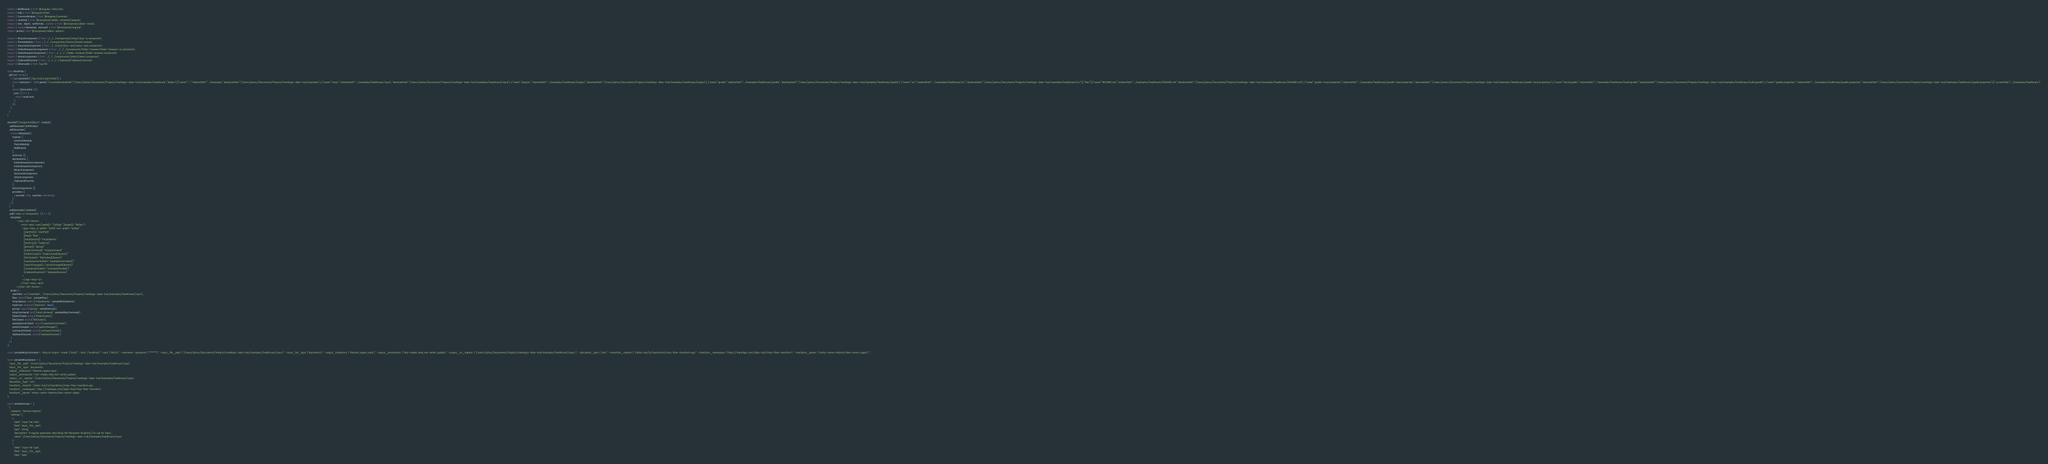Convert code to text. <code><loc_0><loc_0><loc_500><loc_500><_TypeScript_>import { MdlModule } from '@angular-mdl/core';
import { Http } from '@angular/http';
import { CommonModule } from '@angular/common';
import { centered } from '@storybook/addon-centered/angular';
import { text, object, withKnobs, boolean } from '@storybook/addon-knobs';
import { moduleMetadata, storiesOf } from '@storybook/angular';
import {action} from '@storybook/addon-actions';

import { MlcpUiComponent } from '../../../components/mlcp/mlcp-ui.component';
import { ThemeModule } from '../../../components/theme/theme.module';
import { StoryCardComponent } from '../../utils/story-card/story-card.component';
import { FolderBrowserUiComponent } from '../../../components/folder-browser/folder-browser-ui.component';
import { FolderBrowserComponent } from '../../../../folder-browser/folder-browser.component';
import { SelectComponent } from '../../../components/select/select.component';
import { ClipboardDirective } from '../../../../clipboard/clipboard.directive';
import { Observable } from 'rxjs/Rx';

class MockHttp {
  get(uri: string) {
    if (uri.startsWith('/api/utils/searchPath')) {
      const mockJson = JSON.parse('{"currentAbsolutePath":"/Users/pzhou/Documents/Projects/marklogic-data-hub/examples/healthcare","folders":[{"name":"..","relativePath":"../examples","absolutePath":"/Users/pzhou/Documents/Projects/marklogic-data-hub/examples"},{"name":"input","relativePath":"../examples/healthcare/input","absolutePath":"/Users/pzhou/Documents/Projects/marklogic-data-hub/examples/healthcare/input"},{"name":"plugins","relativePath":"../examples/healthcare/plugins","absolutePath":"/Users/pzhou/Documents/Projects/marklogic-data-hub/examples/healthcare/plugins"},{"name":"gradle","relativePath":"../examples/healthcare/gradle","absolutePath":"/Users/pzhou/Documents/Projects/marklogic-data-hub/examples/healthcare/gradle"},{"name":"src","relativePath":"../examples/healthcare/src","absolutePath":"/Users/pzhou/Documents/Projects/marklogic-data-hub/examples/healthcare/src"}],"files":[{"name":"README.md","relativePath":"../examples/healthcare/README.md","absolutePath":"/Users/pzhou/Documents/Projects/marklogic-data-hub/examples/healthcare/README.md"},{"name":"gradle-local.properties","relativePath":"../examples/healthcare/gradle-local.properties","absolutePath":"/Users/pzhou/Documents/Projects/marklogic-data-hub/examples/healthcare/gradle-local.properties"},{"name":"build.gradle","relativePath":"../examples/healthcare/build.gradle","absolutePath":"/Users/pzhou/Documents/Projects/marklogic-data-hub/examples/healthcare/build.gradle"},{"name":"gradle.properties","relativePath":"../examples/healthcare/gradle.properties","absolutePath":"/Users/pzhou/Documents/Projects/marklogic-data-hub/examples/healthcare/gradle.properties"}],"currentPath":"../examples/healthcare"}'
      );
      return Observable.of({
        json: () => {
          return mockJson;
        }
      });
    }
  }
}

storiesOf('Components|MLCP', module)
  .addDecorator(withKnobs)
  .addDecorator(
    moduleMetadata({
      imports: [
        CommonModule,
        ThemeModule,
        MdlModule
      ],
      schemas: [],
      declarations: [
        FolderBrowserUiComponent,
        FolderBrowserComponent,
        MlcpUiComponent,
        StoryCardComponent,
        SelectComponent,
        ClipboardDirective,
      ],
      entryComponents: [],
      providers: [
        { provide: Http, useClass: MockHttp}
      ]
    })
  )
  .addDecorator(centered)
  .add('mlcp-ui Component', () => ({
    template: `
            <mlui-dhf-theme>
                <mlui-story-card [width]="'1300px'" [height]="'800px'">
                  <app-mlcp-ui width="100%" min-width="500px"
                    [startPath]="startPath"
                    [flow]="flow"
                    [mlcpOptions]="mlcpOptions"
                    [hasErrors]="hasErrors"
                    [groups]="groups"
                    [mlcpCommand]="mlcpCommand"
                    (folderClicked)="folderClicked($event)"
                    (fileClicked)="fileClicked($event)"
                    (saveOptionsClicked)="saveOptionsClicked()"
                    (switchChanged)="switchChanged($event)"
                    (runImportClicked)="runImportClicked()"
                    (clipboardSuccess)="clipboardSuccess"
                  >
                  </app-mlcp-ui>
                </mlui-story-card>
           </mlui-dhf-theme>`,
    props: {
      startPath: text('startPath', '/Users/pzhou/Documents/Projects/marklogic-data-hub/examples/healthcare/input'),
      flow: object('flow', sampleFlow),
      mlcpOptions: object('mlcpOptions', sampleMlcpOptions),
      hasErrors: boolean('hasErrors', false),
      groups: object('groups', sampleGroups),
      mlcpCommand: text('mlcpCommand', sampleMlcpCommand),
      folderClicked: action('folderClicked'),
      fileClicked: action('fileClicked'),
      saveOptionsClicked: action('saveOptionsClicked'),
      switchChanged: action('switchChanged'),
      runImportClicked: action('runImportClicked'),
      clipboardSuccess: action('clipboardSuccess')
    }
  })
);

const sampleMlcpCommand = 'mlcp.sh import -mode \"local\" -host \"localhost\" -port \"8010\" -username -password \"*****\" -input_file_path \"/Users/pzhou/Documents/Projects/marklogic-data-hub/examples/healthcare/input\" -input_file_type \"documents\" -output_collections \"Patients,nppes,input\" -output_permissions \"rest-reader,read,rest-writer,update\" -output_uri_replace \"/Users/pzhou/Documents/Projects/marklogic-data-hub/examples/healthcare/input,\" -document_type \"xml\" -transform_module \"/data-hub/4/transforms/mlcp-flow-transform.xqy\" -transform_namespace \"http://marklogic.com/data-hub/mlcp-flow-transform\" -transform_param \"entity-name=Patients,flow-name=nppes\"';

const sampleMlcpOptions = {
  'input_file_path': '/Users/pzhou/Documents/Projects/marklogic-data-hub/examples/healthcare/input',
  'input_file_type': 'documents',
  'output_collections': 'Patients,nppes,input',
  'output_permissions': 'rest-reader,read,rest-writer,update',
  'output_uri_replace': '/Users/pzhou/Documents/Projects/marklogic-data-hub/examples/healthcare/input',
  'document_type': 'xml',
  'transform_module': '/data-hub/4/transforms/mlcp-flow-transform.xqy',
  'transform_namespace': 'http://marklogic.com/data-hub/mlcp-flow-transform',
  'transform_param': 'entity-name=Patients,flow-name=nppes'
};

const sampleGroups = [
  {
    'category': 'General Options',
    'settings': [
      {
        'label': 'Input File Path',
        'field': 'input_file_path',
        'type': 'string',
        'description': 'A regular expression describing the filesystem location(s) to use for input.',
        'value': '/Users/pzhou/Documents/Projects/marklogic-data-hub/examples/healthcare/input'
      },
      {
        'label': 'Input File Type',
        'field': 'input_file_type',
        'type': 'type',</code> 